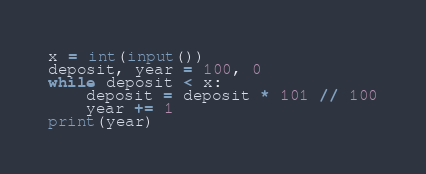<code> <loc_0><loc_0><loc_500><loc_500><_Python_>x = int(input())
deposit, year = 100, 0
while deposit < x:
    deposit = deposit * 101 // 100
    year += 1
print(year)</code> 